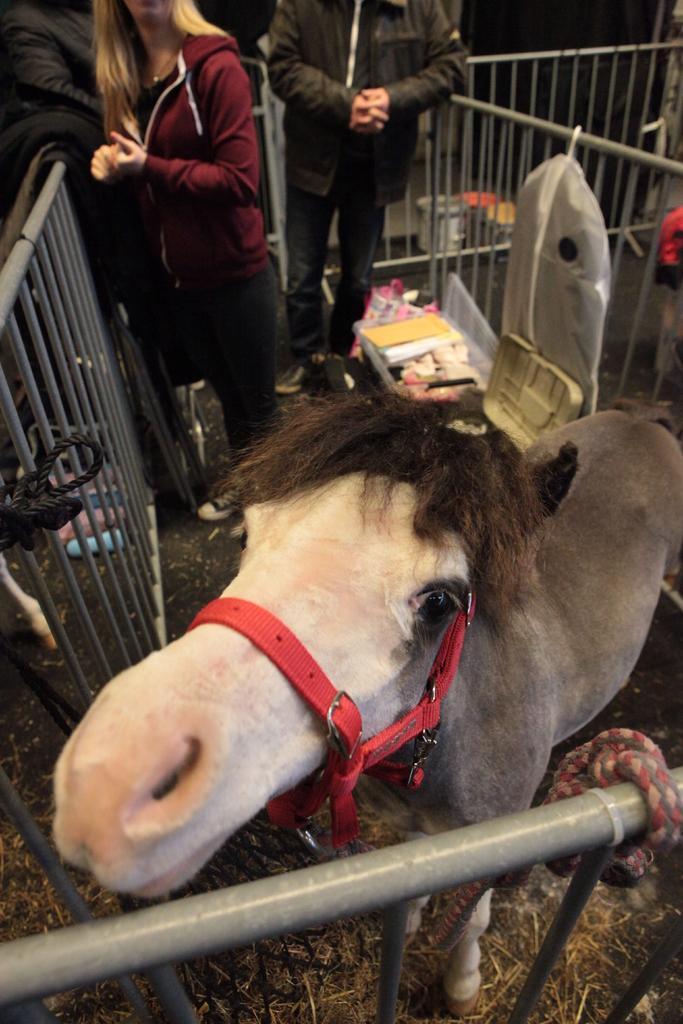Could you give a brief overview of what you see in this image? In this image in the front there is an animal. In the background there are persons standing and on the left side there is metal fence. On the right side there is metal fence and on the fence, there is white colour object hanging and in front of the fence, there are objects. On the ground there is grass which is in the front. 